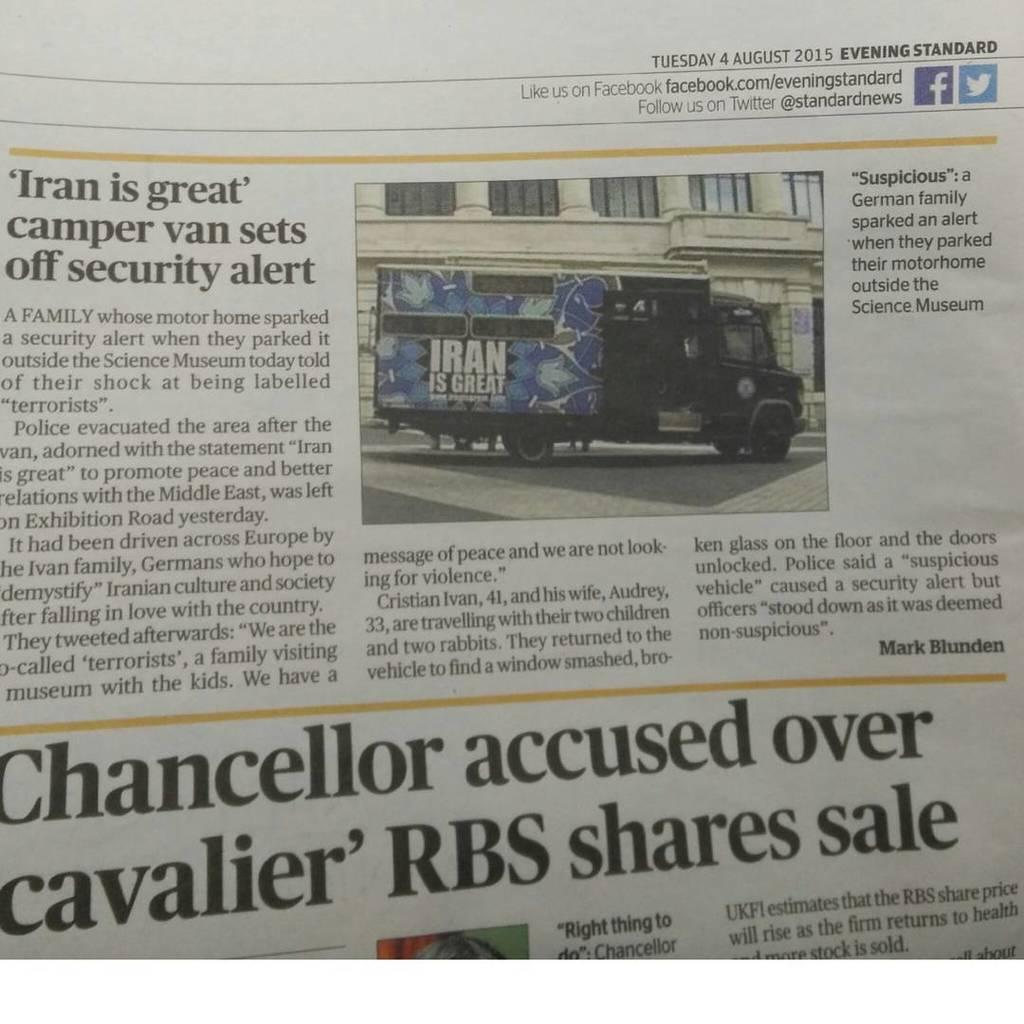What is the main object in the image? There is a newspaper in the image. What can be found within the newspaper? The newspaper contains images and text. What type of bells can be heard ringing in the image? There are no bells present in the image, and therefore no sound can be heard. 